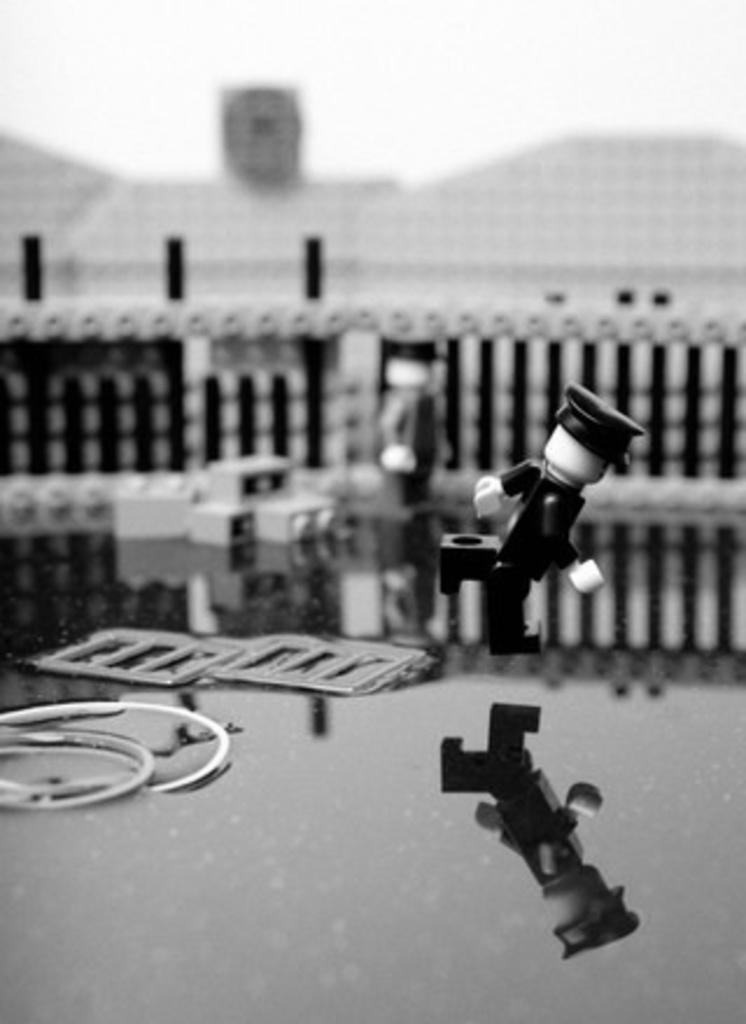What is the color scheme of the image? The image is black and white. What object can be seen in the image? There is a toy in the image. What type of structure is visible in the image? There is a fence in the image. Can you describe the background of the image? The background of the image is blurred. What type of wall can be seen in the image? There is no wall present in the image; it features a toy and a fence. How many thumbs can be seen interacting with the toy in the image? There are no thumbs visible in the image, as it only shows a toy and a fence. 